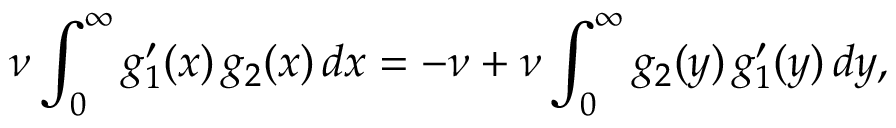<formula> <loc_0><loc_0><loc_500><loc_500>\nu \int _ { 0 } ^ { \infty } g _ { 1 } ^ { \prime } ( x ) \, g _ { 2 } ( x ) \, d x = - \nu + \nu \int _ { 0 } ^ { \infty } g _ { 2 } ( y ) \, g _ { 1 } ^ { \prime } ( y ) \, d y ,</formula> 